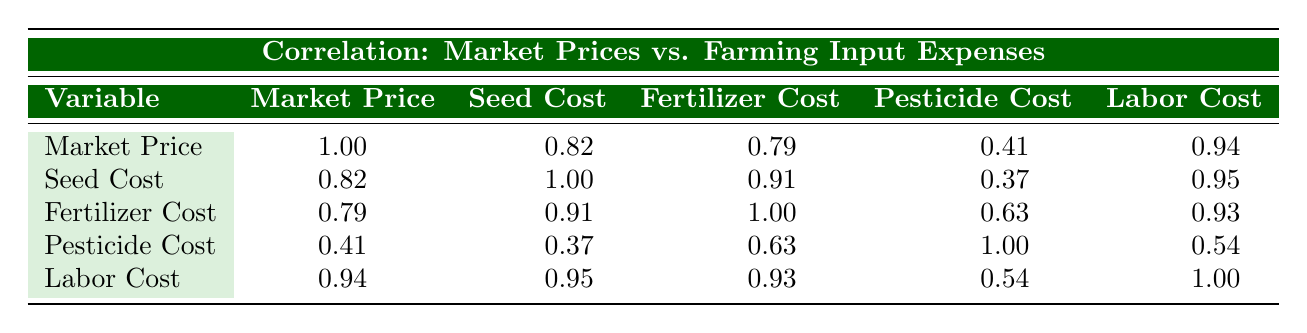What is the market price per kg in 2021? The table shows the market price per kg in 2021 as 3.0. This is found directly in the second row under the "Market Price" column.
Answer: 3.0 What is the seed cost per hectare in 2022? Looking at the table, the seed cost per hectare in 2022 is listed as 170, found in the third row under the "Seed Cost" column.
Answer: 170 Is the correlation between labor cost and market price greater than 0.90? According to the table, the correlation between labor cost and market price is 0.94. Since 0.94 is greater than 0.90, the statement is true.
Answer: Yes What is the difference in market price between 2020 and 2023? In 2020, the market price is 2.5 and in 2023 it is 3.5. The difference is calculated as 3.5 - 2.5 = 1.0.
Answer: 1.0 What is the average seed cost from 2020 to 2023? The seed costs are 150, 160, 170, and 180 for the years 2020, 2021, 2022, and 2023 respectively. The sum is 150 + 160 + 170 + 180 = 660. Divide this by 4 (the number of years) to get an average of 660 / 4 = 165.
Answer: 165 Is there a strong correlation between fertilizer cost and market price? The correlation between fertilizer cost and market price is given as 0.79. This value indicates a moderate to strong positive correlation, typically considered strong if it exceeds 0.70. Thus, it can be stated that the correlation is indeed strong.
Answer: Yes What is the total cost of pesticides and labor per hectare in 2021? The pesticide cost per hectare in 2021 is 120 and the labor cost is 350. The total cost is calculated by adding both values: 120 + 350 = 470.
Answer: 470 In which year did the market price increase the most compared to the previous year? By examining the market prices for each year: 2020 (2.5), 2021 (3.0), 2022 (2.8), and 2023 (3.5), the increases were from 2020 to 2021 (0.5), from 2021 to 2022 (-0.2), and from 2022 to 2023 (0.7). The largest increase is from 2022 to 2023, which is 0.7.
Answer: 2022 to 2023 What is the correlation between seed cost and fertilizer cost? The table indicates that the correlation between seed cost and fertilizer cost is 0.91. This value suggests a strong positive correlation, as it is over 0.90.
Answer: 0.91 